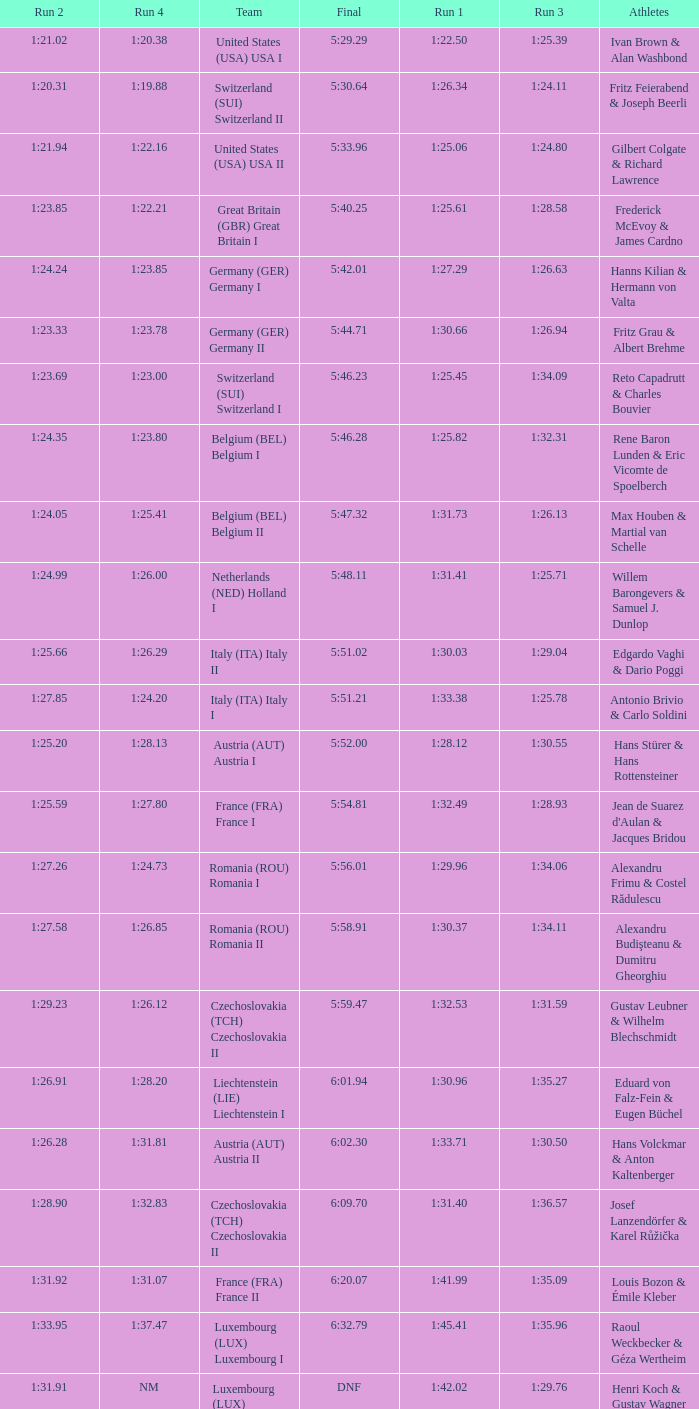Which Run 2 has a Run 1 of 1:30.03? 1:25.66. 